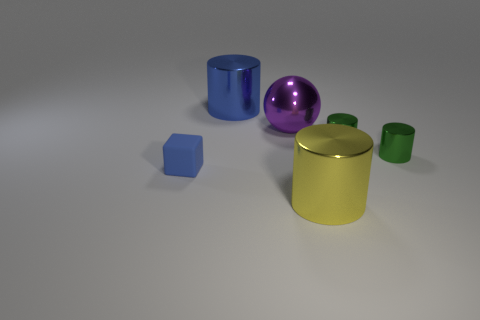Add 1 tiny blue things. How many objects exist? 7 Subtract all blocks. How many objects are left? 5 Add 4 small blue blocks. How many small blue blocks are left? 5 Add 2 large cylinders. How many large cylinders exist? 4 Subtract 0 green cubes. How many objects are left? 6 Subtract all big blue objects. Subtract all big green matte cylinders. How many objects are left? 5 